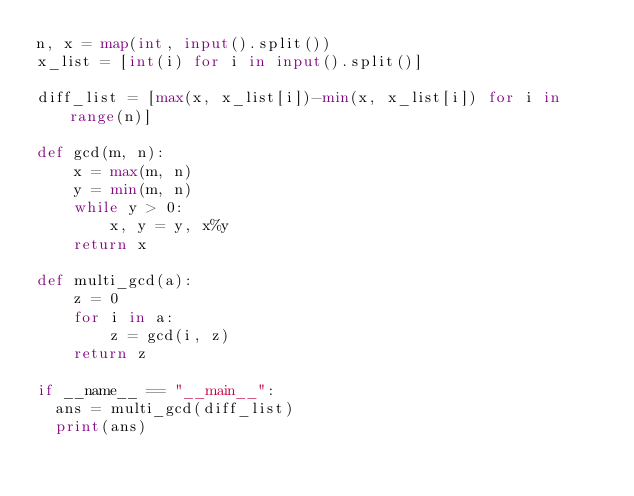Convert code to text. <code><loc_0><loc_0><loc_500><loc_500><_Python_>n, x = map(int, input().split())
x_list = [int(i) for i in input().split()]

diff_list = [max(x, x_list[i])-min(x, x_list[i]) for i in range(n)]

def gcd(m, n):
    x = max(m, n)
    y = min(m, n)
    while y > 0:
        x, y = y, x%y
    return x

def multi_gcd(a):
    z = 0
    for i in a:
        z = gcd(i, z)
    return z
  
if __name__ == "__main__":
  ans = multi_gcd(diff_list)
  print(ans)</code> 